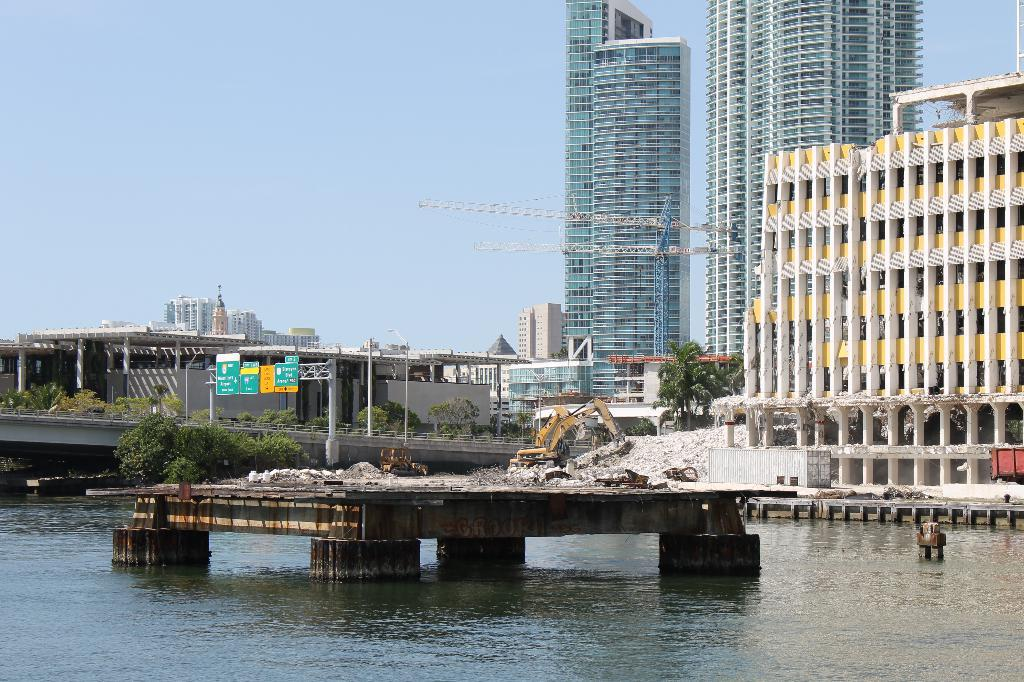What is the main feature of the image? There is water in the image. What is located in the middle of the water? There is a stage in the middle of the water. What type of vegetation can be seen in the image? There are trees visible in the image. What type of structures are present in the image? There are tall buildings in the image. What is the person in the image doing? There is a proclaimer in the image. What is visible above the water and buildings? There is a sky visible in the image. What type of advertisement can be seen on the texture of the water in the image? There is no advertisement visible on the water in the image, and the concept of texture does not apply to water in this context. 